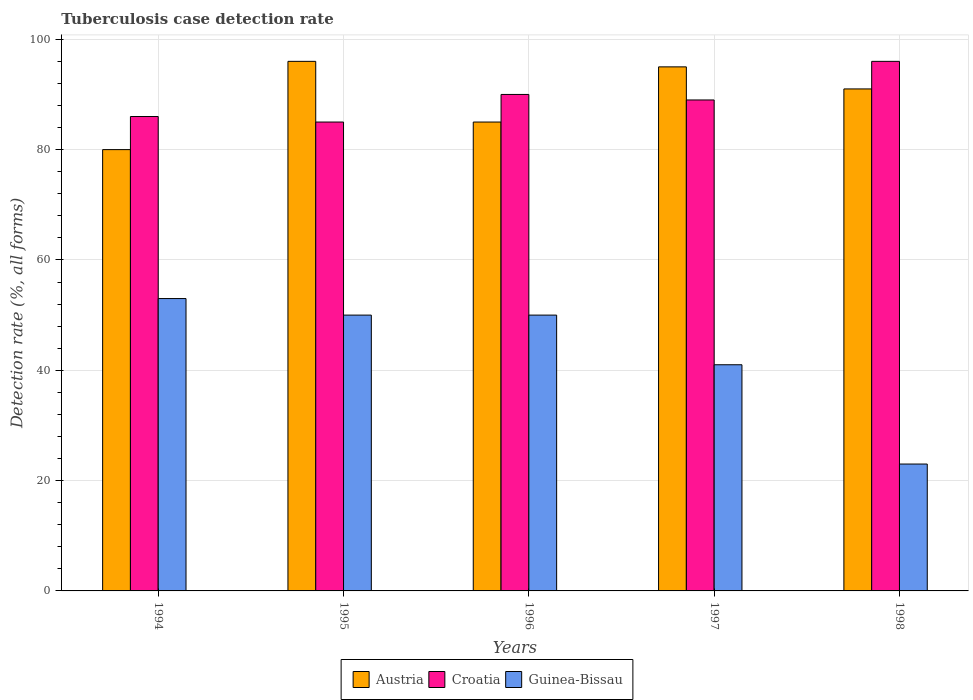Are the number of bars per tick equal to the number of legend labels?
Provide a short and direct response. Yes. How many bars are there on the 1st tick from the left?
Offer a very short reply. 3. What is the label of the 4th group of bars from the left?
Provide a short and direct response. 1997. In how many cases, is the number of bars for a given year not equal to the number of legend labels?
Your response must be concise. 0. What is the tuberculosis case detection rate in in Croatia in 1994?
Keep it short and to the point. 86. Across all years, what is the maximum tuberculosis case detection rate in in Croatia?
Your answer should be compact. 96. What is the total tuberculosis case detection rate in in Austria in the graph?
Offer a very short reply. 447. What is the difference between the tuberculosis case detection rate in in Croatia in 1994 and that in 1997?
Keep it short and to the point. -3. What is the difference between the tuberculosis case detection rate in in Croatia in 1994 and the tuberculosis case detection rate in in Austria in 1995?
Give a very brief answer. -10. What is the average tuberculosis case detection rate in in Guinea-Bissau per year?
Your response must be concise. 43.4. In how many years, is the tuberculosis case detection rate in in Croatia greater than 80 %?
Provide a succinct answer. 5. What is the ratio of the tuberculosis case detection rate in in Guinea-Bissau in 1995 to that in 1996?
Provide a short and direct response. 1. Is the difference between the tuberculosis case detection rate in in Croatia in 1996 and 1997 greater than the difference between the tuberculosis case detection rate in in Austria in 1996 and 1997?
Offer a terse response. Yes. What is the difference between the highest and the second highest tuberculosis case detection rate in in Austria?
Make the answer very short. 1. What is the difference between the highest and the lowest tuberculosis case detection rate in in Croatia?
Provide a succinct answer. 11. Is the sum of the tuberculosis case detection rate in in Austria in 1994 and 1998 greater than the maximum tuberculosis case detection rate in in Guinea-Bissau across all years?
Offer a very short reply. Yes. What does the 1st bar from the left in 1998 represents?
Provide a succinct answer. Austria. What does the 3rd bar from the right in 1998 represents?
Keep it short and to the point. Austria. How many bars are there?
Keep it short and to the point. 15. Are all the bars in the graph horizontal?
Provide a short and direct response. No. How many legend labels are there?
Offer a very short reply. 3. How are the legend labels stacked?
Your answer should be compact. Horizontal. What is the title of the graph?
Offer a very short reply. Tuberculosis case detection rate. Does "Japan" appear as one of the legend labels in the graph?
Your response must be concise. No. What is the label or title of the X-axis?
Make the answer very short. Years. What is the label or title of the Y-axis?
Offer a terse response. Detection rate (%, all forms). What is the Detection rate (%, all forms) in Croatia in 1994?
Ensure brevity in your answer.  86. What is the Detection rate (%, all forms) of Austria in 1995?
Give a very brief answer. 96. What is the Detection rate (%, all forms) in Guinea-Bissau in 1996?
Keep it short and to the point. 50. What is the Detection rate (%, all forms) of Austria in 1997?
Your answer should be very brief. 95. What is the Detection rate (%, all forms) of Croatia in 1997?
Your answer should be compact. 89. What is the Detection rate (%, all forms) in Austria in 1998?
Your response must be concise. 91. What is the Detection rate (%, all forms) in Croatia in 1998?
Provide a succinct answer. 96. What is the Detection rate (%, all forms) of Guinea-Bissau in 1998?
Your answer should be very brief. 23. Across all years, what is the maximum Detection rate (%, all forms) in Austria?
Your answer should be compact. 96. Across all years, what is the maximum Detection rate (%, all forms) of Croatia?
Keep it short and to the point. 96. Across all years, what is the maximum Detection rate (%, all forms) in Guinea-Bissau?
Offer a very short reply. 53. Across all years, what is the minimum Detection rate (%, all forms) in Austria?
Offer a terse response. 80. Across all years, what is the minimum Detection rate (%, all forms) in Guinea-Bissau?
Offer a very short reply. 23. What is the total Detection rate (%, all forms) in Austria in the graph?
Your answer should be compact. 447. What is the total Detection rate (%, all forms) of Croatia in the graph?
Provide a short and direct response. 446. What is the total Detection rate (%, all forms) of Guinea-Bissau in the graph?
Your response must be concise. 217. What is the difference between the Detection rate (%, all forms) in Croatia in 1994 and that in 1995?
Your answer should be compact. 1. What is the difference between the Detection rate (%, all forms) in Guinea-Bissau in 1994 and that in 1995?
Offer a very short reply. 3. What is the difference between the Detection rate (%, all forms) of Austria in 1994 and that in 1996?
Your answer should be compact. -5. What is the difference between the Detection rate (%, all forms) in Guinea-Bissau in 1994 and that in 1996?
Your response must be concise. 3. What is the difference between the Detection rate (%, all forms) of Croatia in 1994 and that in 1997?
Offer a very short reply. -3. What is the difference between the Detection rate (%, all forms) in Guinea-Bissau in 1994 and that in 1997?
Provide a succinct answer. 12. What is the difference between the Detection rate (%, all forms) of Guinea-Bissau in 1994 and that in 1998?
Your answer should be compact. 30. What is the difference between the Detection rate (%, all forms) of Austria in 1995 and that in 1996?
Provide a succinct answer. 11. What is the difference between the Detection rate (%, all forms) in Croatia in 1995 and that in 1997?
Make the answer very short. -4. What is the difference between the Detection rate (%, all forms) in Austria in 1995 and that in 1998?
Provide a short and direct response. 5. What is the difference between the Detection rate (%, all forms) of Croatia in 1995 and that in 1998?
Your answer should be very brief. -11. What is the difference between the Detection rate (%, all forms) of Austria in 1996 and that in 1997?
Provide a succinct answer. -10. What is the difference between the Detection rate (%, all forms) in Guinea-Bissau in 1996 and that in 1997?
Offer a very short reply. 9. What is the difference between the Detection rate (%, all forms) in Guinea-Bissau in 1996 and that in 1998?
Ensure brevity in your answer.  27. What is the difference between the Detection rate (%, all forms) in Austria in 1997 and that in 1998?
Give a very brief answer. 4. What is the difference between the Detection rate (%, all forms) in Guinea-Bissau in 1997 and that in 1998?
Your answer should be very brief. 18. What is the difference between the Detection rate (%, all forms) in Austria in 1994 and the Detection rate (%, all forms) in Guinea-Bissau in 1995?
Give a very brief answer. 30. What is the difference between the Detection rate (%, all forms) of Croatia in 1994 and the Detection rate (%, all forms) of Guinea-Bissau in 1995?
Offer a terse response. 36. What is the difference between the Detection rate (%, all forms) in Austria in 1994 and the Detection rate (%, all forms) in Croatia in 1996?
Keep it short and to the point. -10. What is the difference between the Detection rate (%, all forms) of Austria in 1994 and the Detection rate (%, all forms) of Guinea-Bissau in 1996?
Offer a very short reply. 30. What is the difference between the Detection rate (%, all forms) of Austria in 1994 and the Detection rate (%, all forms) of Croatia in 1997?
Offer a very short reply. -9. What is the difference between the Detection rate (%, all forms) of Croatia in 1994 and the Detection rate (%, all forms) of Guinea-Bissau in 1997?
Give a very brief answer. 45. What is the difference between the Detection rate (%, all forms) in Austria in 1994 and the Detection rate (%, all forms) in Croatia in 1998?
Provide a succinct answer. -16. What is the difference between the Detection rate (%, all forms) in Austria in 1994 and the Detection rate (%, all forms) in Guinea-Bissau in 1998?
Make the answer very short. 57. What is the difference between the Detection rate (%, all forms) in Croatia in 1994 and the Detection rate (%, all forms) in Guinea-Bissau in 1998?
Give a very brief answer. 63. What is the difference between the Detection rate (%, all forms) of Austria in 1995 and the Detection rate (%, all forms) of Croatia in 1996?
Your response must be concise. 6. What is the difference between the Detection rate (%, all forms) of Croatia in 1995 and the Detection rate (%, all forms) of Guinea-Bissau in 1996?
Ensure brevity in your answer.  35. What is the difference between the Detection rate (%, all forms) in Croatia in 1995 and the Detection rate (%, all forms) in Guinea-Bissau in 1997?
Make the answer very short. 44. What is the difference between the Detection rate (%, all forms) of Austria in 1995 and the Detection rate (%, all forms) of Croatia in 1998?
Offer a terse response. 0. What is the difference between the Detection rate (%, all forms) in Austria in 1995 and the Detection rate (%, all forms) in Guinea-Bissau in 1998?
Offer a terse response. 73. What is the difference between the Detection rate (%, all forms) in Austria in 1996 and the Detection rate (%, all forms) in Guinea-Bissau in 1997?
Give a very brief answer. 44. What is the difference between the Detection rate (%, all forms) of Croatia in 1996 and the Detection rate (%, all forms) of Guinea-Bissau in 1998?
Ensure brevity in your answer.  67. What is the difference between the Detection rate (%, all forms) of Austria in 1997 and the Detection rate (%, all forms) of Croatia in 1998?
Your answer should be very brief. -1. What is the average Detection rate (%, all forms) of Austria per year?
Keep it short and to the point. 89.4. What is the average Detection rate (%, all forms) of Croatia per year?
Make the answer very short. 89.2. What is the average Detection rate (%, all forms) of Guinea-Bissau per year?
Your response must be concise. 43.4. In the year 1995, what is the difference between the Detection rate (%, all forms) of Austria and Detection rate (%, all forms) of Croatia?
Make the answer very short. 11. In the year 1995, what is the difference between the Detection rate (%, all forms) in Croatia and Detection rate (%, all forms) in Guinea-Bissau?
Your response must be concise. 35. In the year 1996, what is the difference between the Detection rate (%, all forms) in Croatia and Detection rate (%, all forms) in Guinea-Bissau?
Make the answer very short. 40. In the year 1998, what is the difference between the Detection rate (%, all forms) in Austria and Detection rate (%, all forms) in Croatia?
Keep it short and to the point. -5. In the year 1998, what is the difference between the Detection rate (%, all forms) in Austria and Detection rate (%, all forms) in Guinea-Bissau?
Your answer should be very brief. 68. In the year 1998, what is the difference between the Detection rate (%, all forms) of Croatia and Detection rate (%, all forms) of Guinea-Bissau?
Ensure brevity in your answer.  73. What is the ratio of the Detection rate (%, all forms) in Austria in 1994 to that in 1995?
Offer a terse response. 0.83. What is the ratio of the Detection rate (%, all forms) of Croatia in 1994 to that in 1995?
Provide a succinct answer. 1.01. What is the ratio of the Detection rate (%, all forms) in Guinea-Bissau in 1994 to that in 1995?
Your response must be concise. 1.06. What is the ratio of the Detection rate (%, all forms) in Croatia in 1994 to that in 1996?
Offer a very short reply. 0.96. What is the ratio of the Detection rate (%, all forms) in Guinea-Bissau in 1994 to that in 1996?
Provide a succinct answer. 1.06. What is the ratio of the Detection rate (%, all forms) of Austria in 1994 to that in 1997?
Offer a terse response. 0.84. What is the ratio of the Detection rate (%, all forms) of Croatia in 1994 to that in 1997?
Your answer should be compact. 0.97. What is the ratio of the Detection rate (%, all forms) in Guinea-Bissau in 1994 to that in 1997?
Offer a very short reply. 1.29. What is the ratio of the Detection rate (%, all forms) in Austria in 1994 to that in 1998?
Ensure brevity in your answer.  0.88. What is the ratio of the Detection rate (%, all forms) in Croatia in 1994 to that in 1998?
Ensure brevity in your answer.  0.9. What is the ratio of the Detection rate (%, all forms) in Guinea-Bissau in 1994 to that in 1998?
Provide a succinct answer. 2.3. What is the ratio of the Detection rate (%, all forms) of Austria in 1995 to that in 1996?
Your answer should be very brief. 1.13. What is the ratio of the Detection rate (%, all forms) in Croatia in 1995 to that in 1996?
Offer a terse response. 0.94. What is the ratio of the Detection rate (%, all forms) of Guinea-Bissau in 1995 to that in 1996?
Provide a succinct answer. 1. What is the ratio of the Detection rate (%, all forms) in Austria in 1995 to that in 1997?
Your response must be concise. 1.01. What is the ratio of the Detection rate (%, all forms) in Croatia in 1995 to that in 1997?
Your answer should be compact. 0.96. What is the ratio of the Detection rate (%, all forms) in Guinea-Bissau in 1995 to that in 1997?
Your answer should be compact. 1.22. What is the ratio of the Detection rate (%, all forms) of Austria in 1995 to that in 1998?
Make the answer very short. 1.05. What is the ratio of the Detection rate (%, all forms) of Croatia in 1995 to that in 1998?
Your answer should be compact. 0.89. What is the ratio of the Detection rate (%, all forms) of Guinea-Bissau in 1995 to that in 1998?
Ensure brevity in your answer.  2.17. What is the ratio of the Detection rate (%, all forms) in Austria in 1996 to that in 1997?
Your response must be concise. 0.89. What is the ratio of the Detection rate (%, all forms) in Croatia in 1996 to that in 1997?
Your answer should be compact. 1.01. What is the ratio of the Detection rate (%, all forms) of Guinea-Bissau in 1996 to that in 1997?
Ensure brevity in your answer.  1.22. What is the ratio of the Detection rate (%, all forms) of Austria in 1996 to that in 1998?
Provide a short and direct response. 0.93. What is the ratio of the Detection rate (%, all forms) of Guinea-Bissau in 1996 to that in 1998?
Offer a very short reply. 2.17. What is the ratio of the Detection rate (%, all forms) of Austria in 1997 to that in 1998?
Your answer should be compact. 1.04. What is the ratio of the Detection rate (%, all forms) in Croatia in 1997 to that in 1998?
Offer a very short reply. 0.93. What is the ratio of the Detection rate (%, all forms) in Guinea-Bissau in 1997 to that in 1998?
Provide a succinct answer. 1.78. What is the difference between the highest and the second highest Detection rate (%, all forms) in Croatia?
Ensure brevity in your answer.  6. What is the difference between the highest and the second highest Detection rate (%, all forms) in Guinea-Bissau?
Provide a succinct answer. 3. What is the difference between the highest and the lowest Detection rate (%, all forms) of Austria?
Give a very brief answer. 16. 